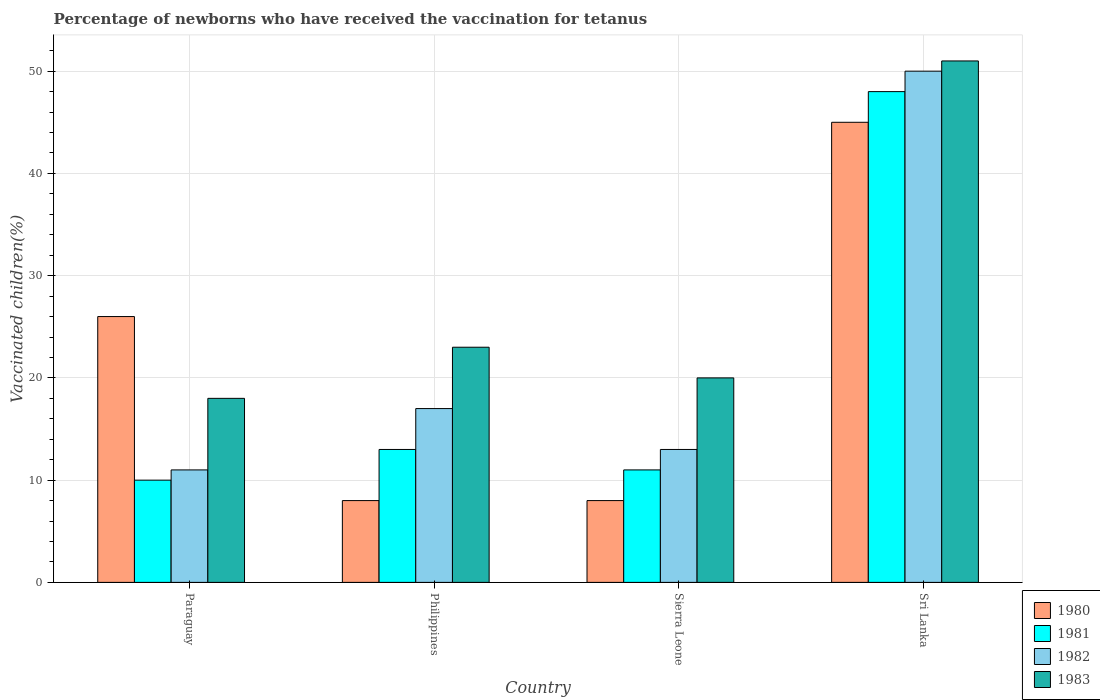How many different coloured bars are there?
Your answer should be very brief. 4. How many groups of bars are there?
Provide a succinct answer. 4. How many bars are there on the 4th tick from the left?
Make the answer very short. 4. What is the label of the 3rd group of bars from the left?
Your answer should be compact. Sierra Leone. What is the percentage of vaccinated children in 1982 in Sierra Leone?
Offer a very short reply. 13. Across all countries, what is the maximum percentage of vaccinated children in 1982?
Provide a short and direct response. 50. In which country was the percentage of vaccinated children in 1982 maximum?
Ensure brevity in your answer.  Sri Lanka. In which country was the percentage of vaccinated children in 1983 minimum?
Your answer should be very brief. Paraguay. What is the total percentage of vaccinated children in 1980 in the graph?
Your answer should be very brief. 87. What is the difference between the percentage of vaccinated children in 1983 in Paraguay and that in Sri Lanka?
Your answer should be very brief. -33. What is the average percentage of vaccinated children in 1981 per country?
Offer a terse response. 20.5. In how many countries, is the percentage of vaccinated children in 1981 greater than 26 %?
Provide a short and direct response. 1. What is the ratio of the percentage of vaccinated children in 1982 in Philippines to that in Sierra Leone?
Give a very brief answer. 1.31. Is the percentage of vaccinated children in 1983 in Sierra Leone less than that in Sri Lanka?
Ensure brevity in your answer.  Yes. What is the difference between the highest and the second highest percentage of vaccinated children in 1982?
Provide a short and direct response. -33. Is it the case that in every country, the sum of the percentage of vaccinated children in 1983 and percentage of vaccinated children in 1980 is greater than the sum of percentage of vaccinated children in 1982 and percentage of vaccinated children in 1981?
Your answer should be very brief. No. What does the 4th bar from the left in Philippines represents?
Your answer should be very brief. 1983. What does the 3rd bar from the right in Philippines represents?
Make the answer very short. 1981. How many countries are there in the graph?
Make the answer very short. 4. Are the values on the major ticks of Y-axis written in scientific E-notation?
Provide a succinct answer. No. Does the graph contain any zero values?
Your answer should be very brief. No. Where does the legend appear in the graph?
Give a very brief answer. Bottom right. How are the legend labels stacked?
Offer a terse response. Vertical. What is the title of the graph?
Give a very brief answer. Percentage of newborns who have received the vaccination for tetanus. What is the label or title of the X-axis?
Offer a terse response. Country. What is the label or title of the Y-axis?
Ensure brevity in your answer.  Vaccinated children(%). What is the Vaccinated children(%) of 1983 in Paraguay?
Offer a terse response. 18. What is the Vaccinated children(%) of 1980 in Philippines?
Provide a short and direct response. 8. What is the Vaccinated children(%) in 1982 in Philippines?
Ensure brevity in your answer.  17. What is the Vaccinated children(%) of 1980 in Sierra Leone?
Your answer should be very brief. 8. What is the Vaccinated children(%) of 1982 in Sierra Leone?
Your answer should be very brief. 13. What is the Vaccinated children(%) of 1980 in Sri Lanka?
Your answer should be very brief. 45. What is the Vaccinated children(%) in 1982 in Sri Lanka?
Keep it short and to the point. 50. What is the Vaccinated children(%) in 1983 in Sri Lanka?
Provide a succinct answer. 51. Across all countries, what is the maximum Vaccinated children(%) in 1983?
Provide a succinct answer. 51. Across all countries, what is the minimum Vaccinated children(%) in 1980?
Offer a very short reply. 8. Across all countries, what is the minimum Vaccinated children(%) in 1981?
Your response must be concise. 10. Across all countries, what is the minimum Vaccinated children(%) in 1983?
Your answer should be compact. 18. What is the total Vaccinated children(%) of 1980 in the graph?
Your answer should be compact. 87. What is the total Vaccinated children(%) in 1982 in the graph?
Provide a short and direct response. 91. What is the total Vaccinated children(%) in 1983 in the graph?
Your answer should be compact. 112. What is the difference between the Vaccinated children(%) in 1980 in Paraguay and that in Philippines?
Provide a short and direct response. 18. What is the difference between the Vaccinated children(%) of 1981 in Paraguay and that in Philippines?
Offer a terse response. -3. What is the difference between the Vaccinated children(%) in 1980 in Paraguay and that in Sri Lanka?
Offer a very short reply. -19. What is the difference between the Vaccinated children(%) of 1981 in Paraguay and that in Sri Lanka?
Your answer should be very brief. -38. What is the difference between the Vaccinated children(%) in 1982 in Paraguay and that in Sri Lanka?
Offer a terse response. -39. What is the difference between the Vaccinated children(%) of 1983 in Paraguay and that in Sri Lanka?
Your response must be concise. -33. What is the difference between the Vaccinated children(%) in 1980 in Philippines and that in Sierra Leone?
Your answer should be compact. 0. What is the difference between the Vaccinated children(%) of 1981 in Philippines and that in Sierra Leone?
Keep it short and to the point. 2. What is the difference between the Vaccinated children(%) in 1982 in Philippines and that in Sierra Leone?
Your answer should be very brief. 4. What is the difference between the Vaccinated children(%) in 1983 in Philippines and that in Sierra Leone?
Your response must be concise. 3. What is the difference between the Vaccinated children(%) of 1980 in Philippines and that in Sri Lanka?
Your answer should be very brief. -37. What is the difference between the Vaccinated children(%) in 1981 in Philippines and that in Sri Lanka?
Your response must be concise. -35. What is the difference between the Vaccinated children(%) of 1982 in Philippines and that in Sri Lanka?
Make the answer very short. -33. What is the difference between the Vaccinated children(%) in 1983 in Philippines and that in Sri Lanka?
Your answer should be very brief. -28. What is the difference between the Vaccinated children(%) of 1980 in Sierra Leone and that in Sri Lanka?
Make the answer very short. -37. What is the difference between the Vaccinated children(%) of 1981 in Sierra Leone and that in Sri Lanka?
Provide a succinct answer. -37. What is the difference between the Vaccinated children(%) of 1982 in Sierra Leone and that in Sri Lanka?
Provide a succinct answer. -37. What is the difference between the Vaccinated children(%) in 1983 in Sierra Leone and that in Sri Lanka?
Ensure brevity in your answer.  -31. What is the difference between the Vaccinated children(%) of 1980 in Paraguay and the Vaccinated children(%) of 1982 in Philippines?
Give a very brief answer. 9. What is the difference between the Vaccinated children(%) in 1982 in Paraguay and the Vaccinated children(%) in 1983 in Philippines?
Provide a short and direct response. -12. What is the difference between the Vaccinated children(%) of 1980 in Paraguay and the Vaccinated children(%) of 1983 in Sierra Leone?
Give a very brief answer. 6. What is the difference between the Vaccinated children(%) in 1981 in Paraguay and the Vaccinated children(%) in 1982 in Sierra Leone?
Your answer should be compact. -3. What is the difference between the Vaccinated children(%) of 1981 in Paraguay and the Vaccinated children(%) of 1983 in Sierra Leone?
Keep it short and to the point. -10. What is the difference between the Vaccinated children(%) in 1980 in Paraguay and the Vaccinated children(%) in 1981 in Sri Lanka?
Keep it short and to the point. -22. What is the difference between the Vaccinated children(%) of 1981 in Paraguay and the Vaccinated children(%) of 1983 in Sri Lanka?
Make the answer very short. -41. What is the difference between the Vaccinated children(%) in 1982 in Paraguay and the Vaccinated children(%) in 1983 in Sri Lanka?
Keep it short and to the point. -40. What is the difference between the Vaccinated children(%) in 1980 in Philippines and the Vaccinated children(%) in 1983 in Sierra Leone?
Offer a very short reply. -12. What is the difference between the Vaccinated children(%) in 1982 in Philippines and the Vaccinated children(%) in 1983 in Sierra Leone?
Offer a terse response. -3. What is the difference between the Vaccinated children(%) of 1980 in Philippines and the Vaccinated children(%) of 1981 in Sri Lanka?
Keep it short and to the point. -40. What is the difference between the Vaccinated children(%) of 1980 in Philippines and the Vaccinated children(%) of 1982 in Sri Lanka?
Your response must be concise. -42. What is the difference between the Vaccinated children(%) in 1980 in Philippines and the Vaccinated children(%) in 1983 in Sri Lanka?
Your response must be concise. -43. What is the difference between the Vaccinated children(%) in 1981 in Philippines and the Vaccinated children(%) in 1982 in Sri Lanka?
Your answer should be very brief. -37. What is the difference between the Vaccinated children(%) of 1981 in Philippines and the Vaccinated children(%) of 1983 in Sri Lanka?
Your answer should be very brief. -38. What is the difference between the Vaccinated children(%) in 1982 in Philippines and the Vaccinated children(%) in 1983 in Sri Lanka?
Make the answer very short. -34. What is the difference between the Vaccinated children(%) in 1980 in Sierra Leone and the Vaccinated children(%) in 1982 in Sri Lanka?
Give a very brief answer. -42. What is the difference between the Vaccinated children(%) in 1980 in Sierra Leone and the Vaccinated children(%) in 1983 in Sri Lanka?
Give a very brief answer. -43. What is the difference between the Vaccinated children(%) in 1981 in Sierra Leone and the Vaccinated children(%) in 1982 in Sri Lanka?
Make the answer very short. -39. What is the difference between the Vaccinated children(%) in 1982 in Sierra Leone and the Vaccinated children(%) in 1983 in Sri Lanka?
Your response must be concise. -38. What is the average Vaccinated children(%) of 1980 per country?
Your response must be concise. 21.75. What is the average Vaccinated children(%) of 1982 per country?
Provide a succinct answer. 22.75. What is the average Vaccinated children(%) in 1983 per country?
Offer a very short reply. 28. What is the difference between the Vaccinated children(%) in 1980 and Vaccinated children(%) in 1981 in Paraguay?
Offer a very short reply. 16. What is the difference between the Vaccinated children(%) in 1980 and Vaccinated children(%) in 1982 in Paraguay?
Ensure brevity in your answer.  15. What is the difference between the Vaccinated children(%) of 1980 and Vaccinated children(%) of 1983 in Paraguay?
Keep it short and to the point. 8. What is the difference between the Vaccinated children(%) in 1981 and Vaccinated children(%) in 1983 in Paraguay?
Ensure brevity in your answer.  -8. What is the difference between the Vaccinated children(%) of 1982 and Vaccinated children(%) of 1983 in Paraguay?
Provide a short and direct response. -7. What is the difference between the Vaccinated children(%) in 1980 and Vaccinated children(%) in 1982 in Philippines?
Your answer should be compact. -9. What is the difference between the Vaccinated children(%) in 1980 and Vaccinated children(%) in 1983 in Philippines?
Offer a terse response. -15. What is the difference between the Vaccinated children(%) of 1981 and Vaccinated children(%) of 1982 in Philippines?
Offer a terse response. -4. What is the difference between the Vaccinated children(%) in 1981 and Vaccinated children(%) in 1983 in Philippines?
Offer a very short reply. -10. What is the difference between the Vaccinated children(%) in 1980 and Vaccinated children(%) in 1982 in Sierra Leone?
Provide a short and direct response. -5. What is the difference between the Vaccinated children(%) in 1981 and Vaccinated children(%) in 1982 in Sierra Leone?
Your answer should be very brief. -2. What is the difference between the Vaccinated children(%) in 1981 and Vaccinated children(%) in 1983 in Sierra Leone?
Keep it short and to the point. -9. What is the difference between the Vaccinated children(%) of 1980 and Vaccinated children(%) of 1983 in Sri Lanka?
Ensure brevity in your answer.  -6. What is the difference between the Vaccinated children(%) of 1981 and Vaccinated children(%) of 1982 in Sri Lanka?
Your answer should be very brief. -2. What is the difference between the Vaccinated children(%) of 1981 and Vaccinated children(%) of 1983 in Sri Lanka?
Your answer should be compact. -3. What is the ratio of the Vaccinated children(%) of 1980 in Paraguay to that in Philippines?
Give a very brief answer. 3.25. What is the ratio of the Vaccinated children(%) of 1981 in Paraguay to that in Philippines?
Your answer should be very brief. 0.77. What is the ratio of the Vaccinated children(%) of 1982 in Paraguay to that in Philippines?
Keep it short and to the point. 0.65. What is the ratio of the Vaccinated children(%) of 1983 in Paraguay to that in Philippines?
Your answer should be very brief. 0.78. What is the ratio of the Vaccinated children(%) in 1981 in Paraguay to that in Sierra Leone?
Ensure brevity in your answer.  0.91. What is the ratio of the Vaccinated children(%) of 1982 in Paraguay to that in Sierra Leone?
Make the answer very short. 0.85. What is the ratio of the Vaccinated children(%) in 1983 in Paraguay to that in Sierra Leone?
Make the answer very short. 0.9. What is the ratio of the Vaccinated children(%) in 1980 in Paraguay to that in Sri Lanka?
Your answer should be compact. 0.58. What is the ratio of the Vaccinated children(%) of 1981 in Paraguay to that in Sri Lanka?
Offer a very short reply. 0.21. What is the ratio of the Vaccinated children(%) in 1982 in Paraguay to that in Sri Lanka?
Your answer should be compact. 0.22. What is the ratio of the Vaccinated children(%) in 1983 in Paraguay to that in Sri Lanka?
Provide a short and direct response. 0.35. What is the ratio of the Vaccinated children(%) in 1980 in Philippines to that in Sierra Leone?
Keep it short and to the point. 1. What is the ratio of the Vaccinated children(%) in 1981 in Philippines to that in Sierra Leone?
Make the answer very short. 1.18. What is the ratio of the Vaccinated children(%) of 1982 in Philippines to that in Sierra Leone?
Your response must be concise. 1.31. What is the ratio of the Vaccinated children(%) of 1983 in Philippines to that in Sierra Leone?
Your answer should be very brief. 1.15. What is the ratio of the Vaccinated children(%) of 1980 in Philippines to that in Sri Lanka?
Offer a very short reply. 0.18. What is the ratio of the Vaccinated children(%) in 1981 in Philippines to that in Sri Lanka?
Keep it short and to the point. 0.27. What is the ratio of the Vaccinated children(%) of 1982 in Philippines to that in Sri Lanka?
Your response must be concise. 0.34. What is the ratio of the Vaccinated children(%) of 1983 in Philippines to that in Sri Lanka?
Provide a succinct answer. 0.45. What is the ratio of the Vaccinated children(%) in 1980 in Sierra Leone to that in Sri Lanka?
Offer a terse response. 0.18. What is the ratio of the Vaccinated children(%) of 1981 in Sierra Leone to that in Sri Lanka?
Ensure brevity in your answer.  0.23. What is the ratio of the Vaccinated children(%) of 1982 in Sierra Leone to that in Sri Lanka?
Offer a very short reply. 0.26. What is the ratio of the Vaccinated children(%) of 1983 in Sierra Leone to that in Sri Lanka?
Give a very brief answer. 0.39. What is the difference between the highest and the lowest Vaccinated children(%) of 1980?
Provide a short and direct response. 37. What is the difference between the highest and the lowest Vaccinated children(%) in 1981?
Ensure brevity in your answer.  38. 